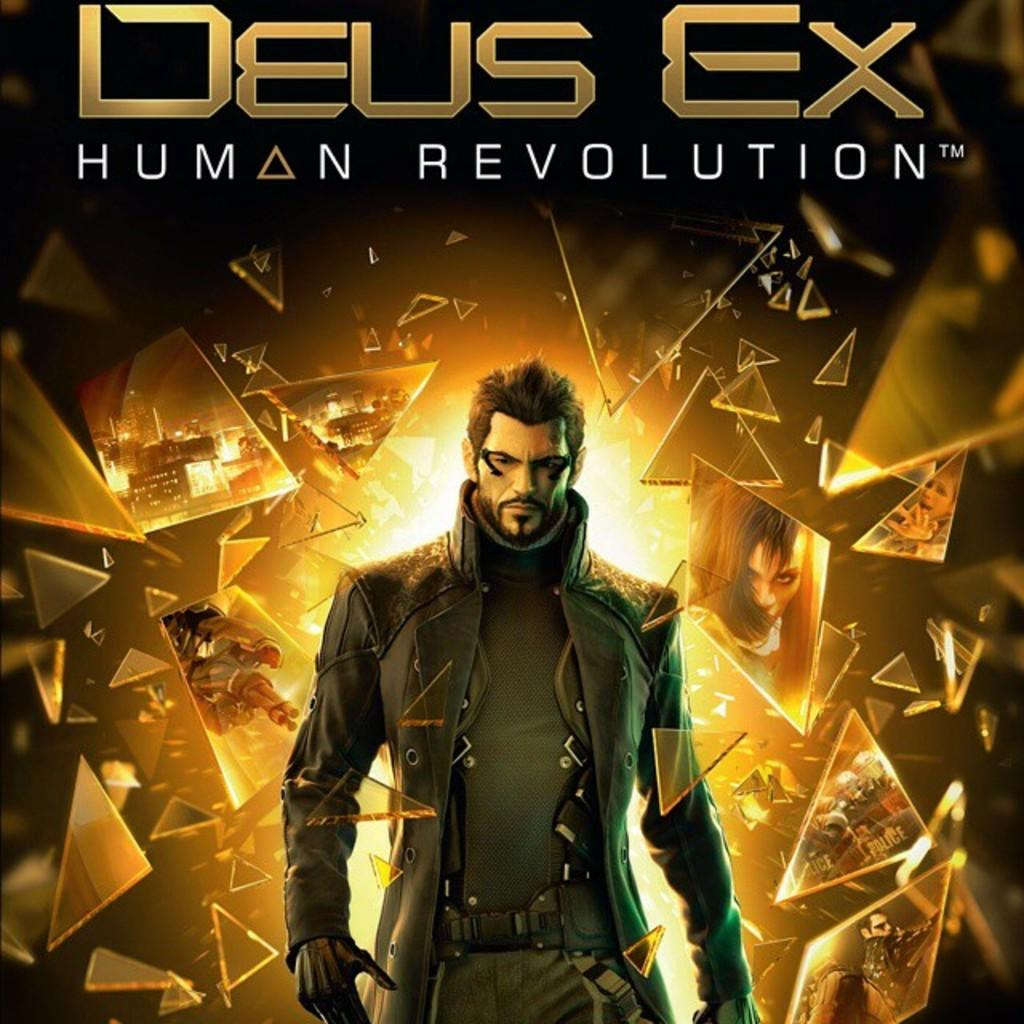<image>
Describe the image concisely. Video game poster that says Deus Ex Human Revolution 